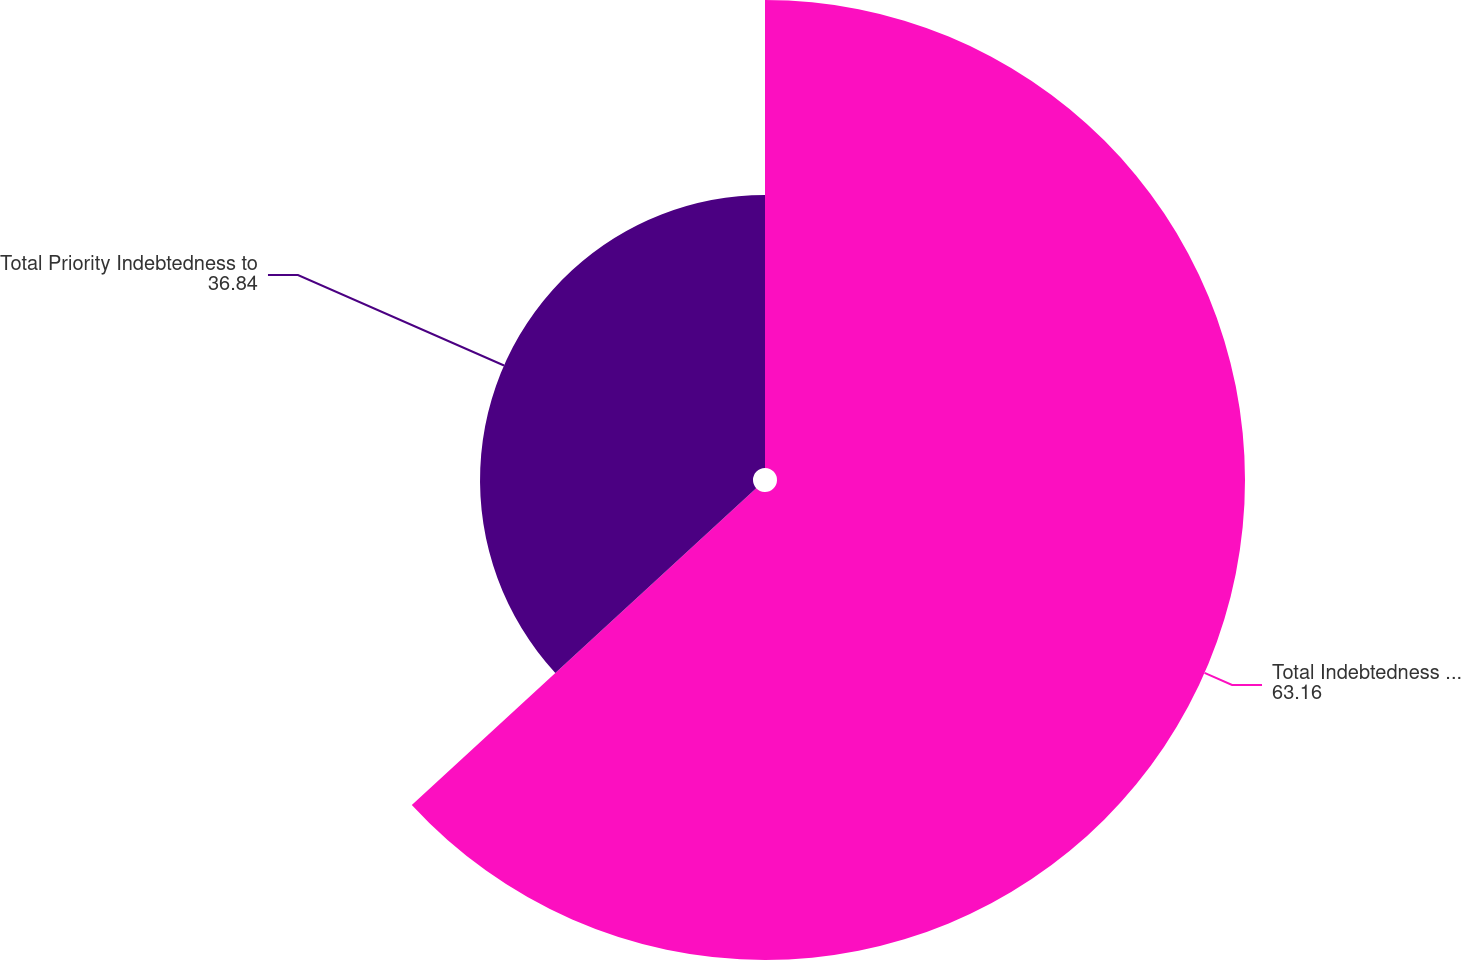Convert chart. <chart><loc_0><loc_0><loc_500><loc_500><pie_chart><fcel>Total Indebtedness to Gross<fcel>Total Priority Indebtedness to<nl><fcel>63.16%<fcel>36.84%<nl></chart> 